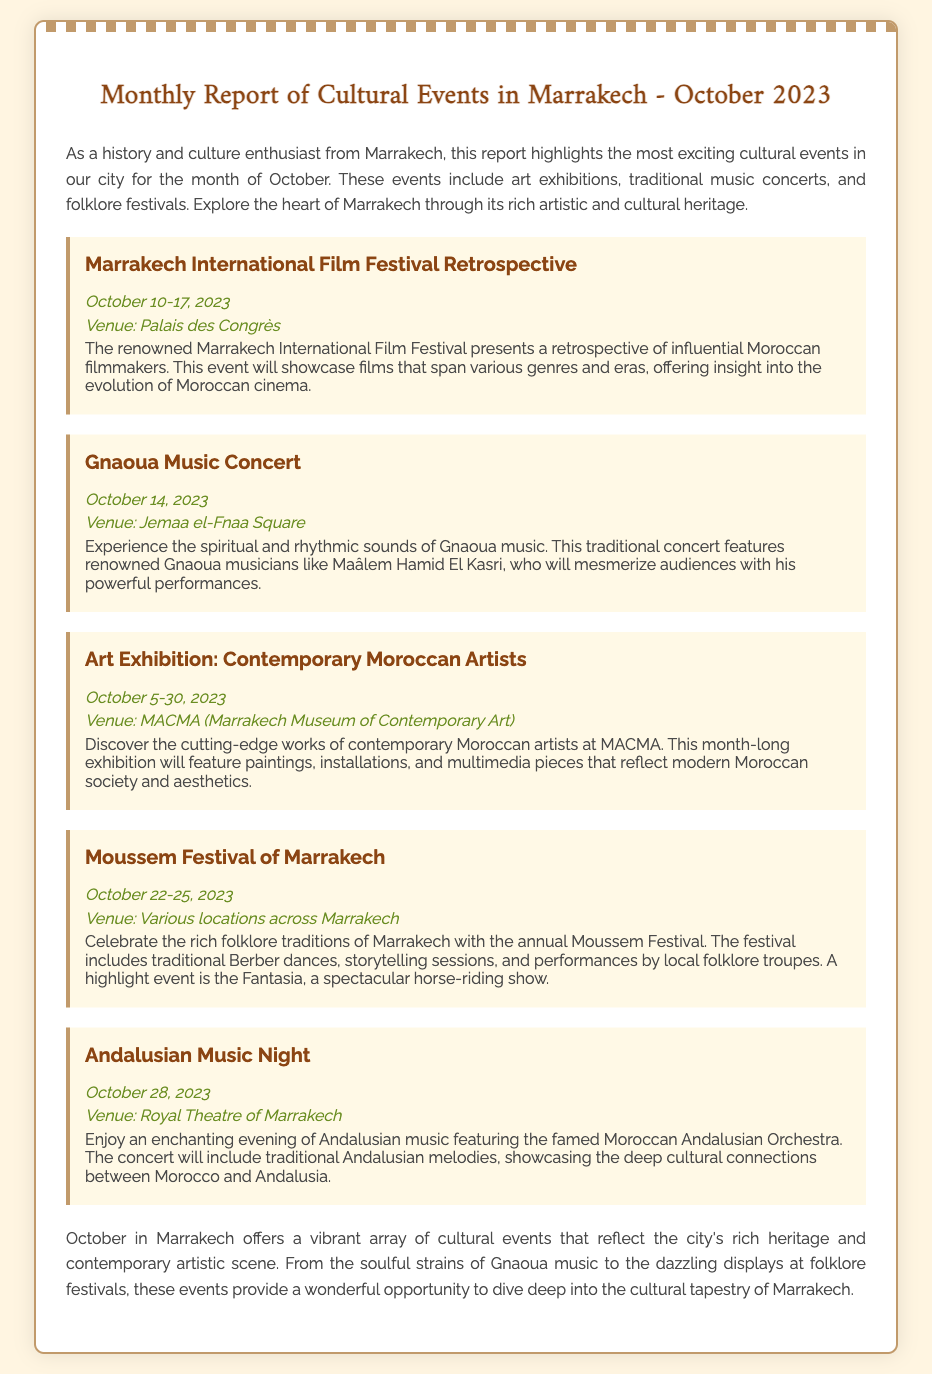what event takes place from October 10 to 17, 2023? The event that takes place during this time is the Marrakech International Film Festival Retrospective.
Answer: Marrakech International Film Festival Retrospective who performs at the Gnaoua Music Concert? The concert features renowned Gnaoua musicians like Maâlem Hamid El Kasri.
Answer: Maâlem Hamid El Kasri what is the venue for the Art Exhibition: Contemporary Moroccan Artists? The venue for this exhibition is MACMA (Marrakech Museum of Contemporary Art).
Answer: MACMA (Marrakech Museum of Contemporary Art) how many days does the Moussem Festival of Marrakech run? The Moussem Festival takes place over four days, from October 22 to October 25.
Answer: four days what type of music is highlighted in the Andalusian Music Night? The music highlighted during this event is Andalusian music.
Answer: Andalusian music which event showcases works of contemporary artists? The event that showcases works of contemporary artists is the Art Exhibition: Contemporary Moroccan Artists.
Answer: Art Exhibition: Contemporary Moroccan Artists what traditional performances are featured in the Moussem Festival? The Moussem Festival features traditional Berber dances and storytelling sessions.
Answer: traditional Berber dances and storytelling sessions when does the Art Exhibition start? The Art Exhibition starts on October 5, 2023.
Answer: October 5, 2023 